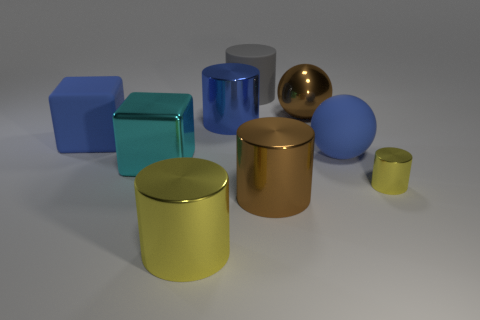There is a yellow metal cylinder in front of the yellow cylinder that is on the right side of the matte cylinder; are there any cylinders that are behind it?
Keep it short and to the point. Yes. Are there any blue rubber objects to the left of the big gray rubber cylinder?
Keep it short and to the point. Yes. How many other objects are there of the same shape as the small yellow metal object?
Ensure brevity in your answer.  4. The other sphere that is the same size as the metal ball is what color?
Your answer should be very brief. Blue. Is the number of large matte things on the right side of the small yellow cylinder less than the number of big objects in front of the gray cylinder?
Keep it short and to the point. Yes. How many objects are on the left side of the yellow object to the left of the cylinder that is behind the large brown sphere?
Your answer should be compact. 2. There is another yellow object that is the same shape as the large yellow object; what size is it?
Give a very brief answer. Small. Is the number of brown metal objects that are behind the small yellow cylinder less than the number of large red rubber balls?
Your answer should be very brief. No. Does the large yellow thing have the same shape as the gray object?
Keep it short and to the point. Yes. There is another large rubber object that is the same shape as the big cyan object; what color is it?
Give a very brief answer. Blue. 